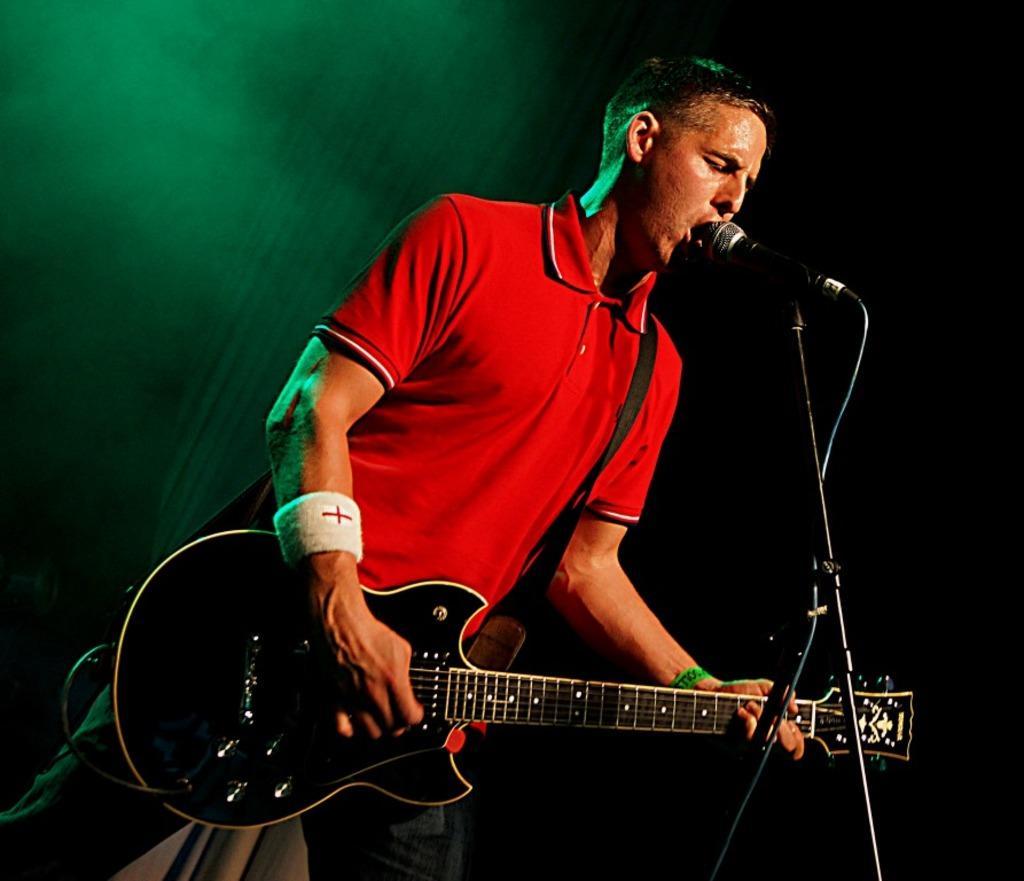How would you summarize this image in a sentence or two? In this image i can see a man standing playing the guitar and singing song in the microphone. 